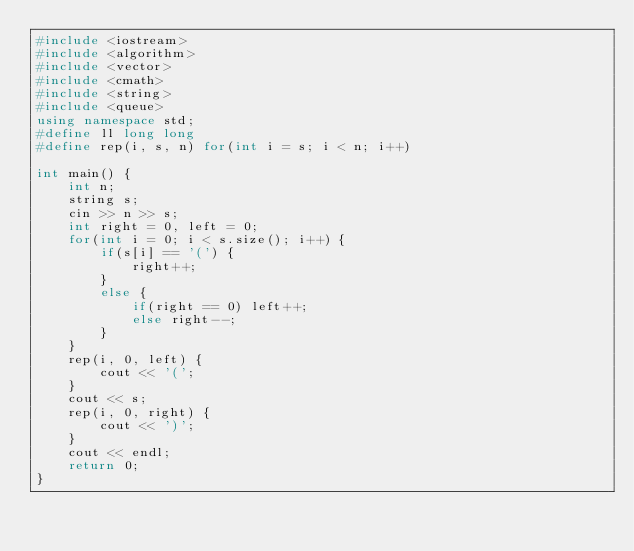Convert code to text. <code><loc_0><loc_0><loc_500><loc_500><_C++_>#include <iostream>
#include <algorithm>
#include <vector>
#include <cmath>
#include <string>
#include <queue>
using namespace std;
#define ll long long
#define rep(i, s, n) for(int i = s; i < n; i++)

int main() {
    int n;
    string s;
    cin >> n >> s;
    int right = 0, left = 0;
    for(int i = 0; i < s.size(); i++) {
        if(s[i] == '(') {
            right++;
        }
        else {
            if(right == 0) left++;
            else right--;
        }
    }
    rep(i, 0, left) {
        cout << '(';
    }
    cout << s;
    rep(i, 0, right) {
        cout << ')';
    }
    cout << endl;
    return 0;
}</code> 